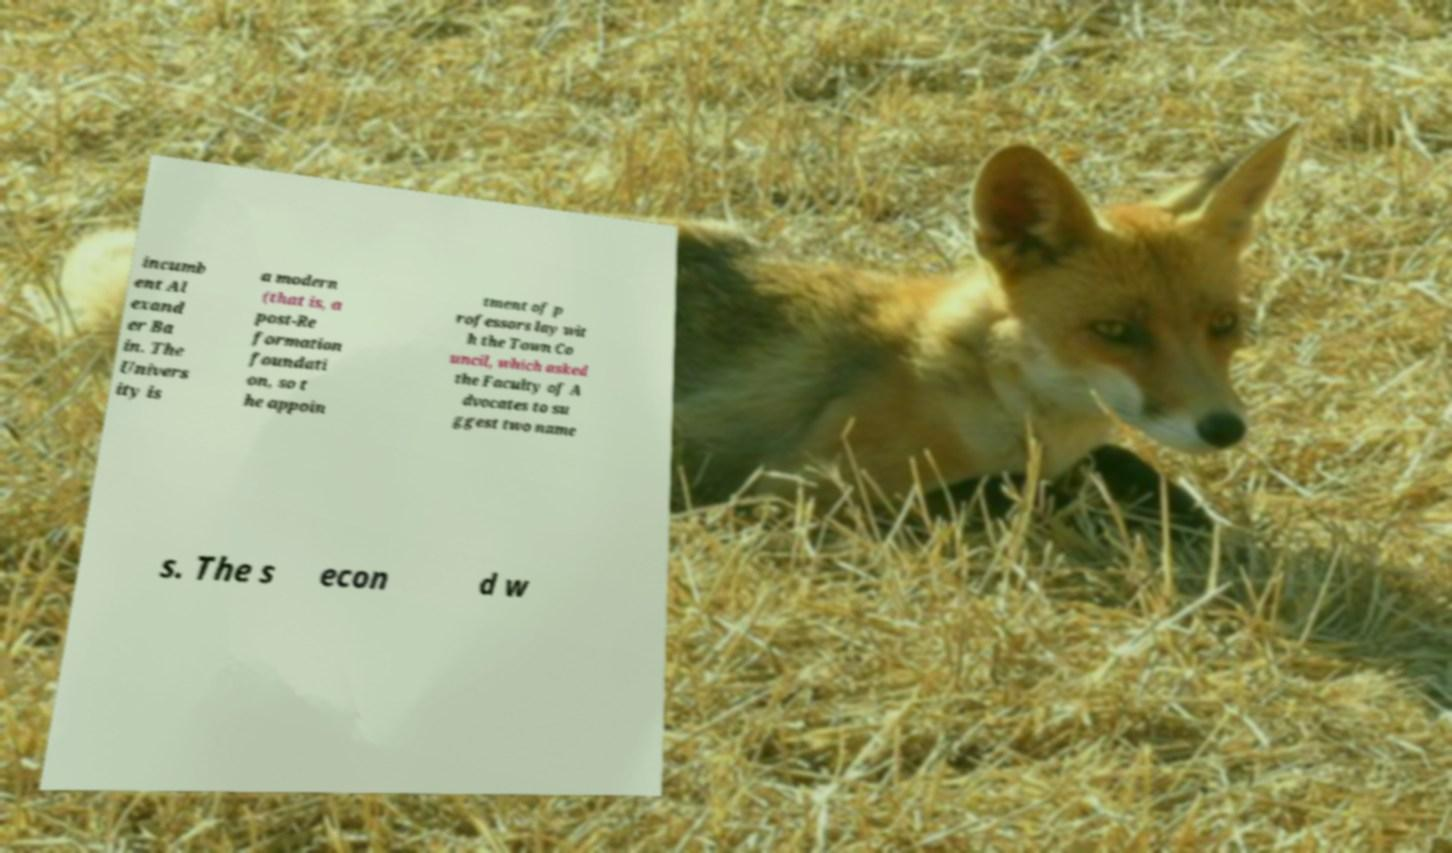There's text embedded in this image that I need extracted. Can you transcribe it verbatim? incumb ent Al exand er Ba in. The Univers ity is a modern (that is, a post-Re formation foundati on, so t he appoin tment of p rofessors lay wit h the Town Co uncil, which asked the Faculty of A dvocates to su ggest two name s. The s econ d w 